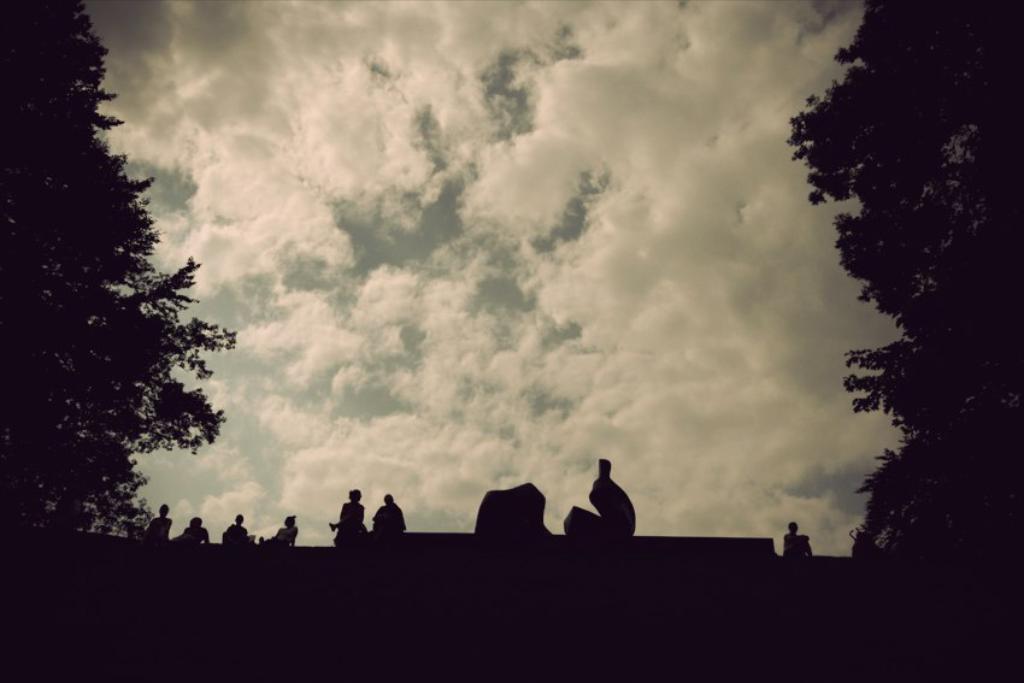Please provide a concise description of this image. In this image, we can see persons. There is a tree on the left and on the right side of the image. There are clouds in the sky. 